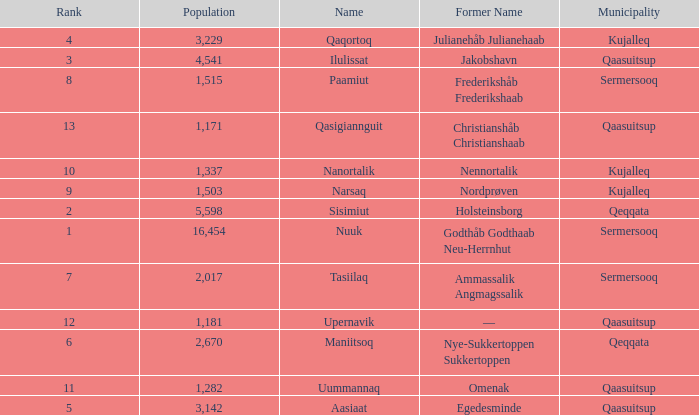What is the population for Rank 11? 1282.0. 